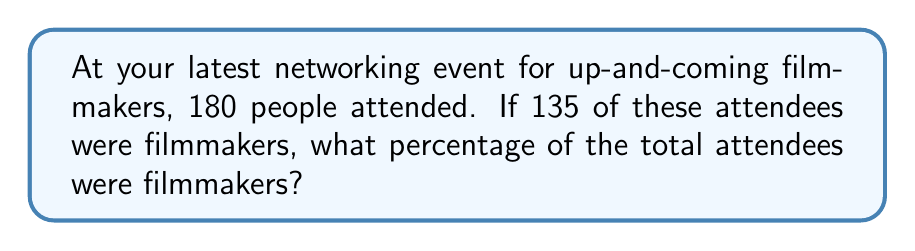Help me with this question. To calculate the percentage of filmmakers attending the event, we need to follow these steps:

1. Identify the total number of attendees: 180
2. Identify the number of filmmakers: 135
3. Use the formula for percentage: $\text{Percentage} = \frac{\text{Part}}{\text{Whole}} \times 100\%$

Let's plug in our values:

$$\text{Percentage of filmmakers} = \frac{135}{180} \times 100\%$$

Now, let's simplify the fraction:

$$\frac{135}{180} = \frac{3}{4} = 0.75$$

Finally, multiply by 100% to get the percentage:

$$0.75 \times 100\% = 75\%$$

Therefore, 75% of the total attendees were filmmakers.
Answer: 75% 